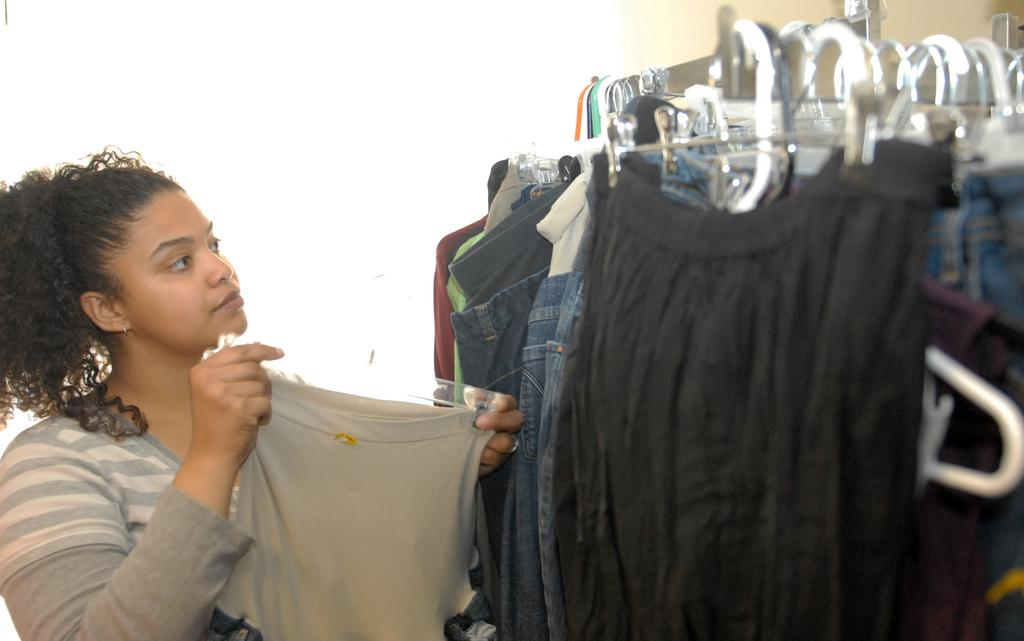What is the main subject of the image? There is a woman standing in the center of the image. What is the woman holding in the image? The woman is holding a cloth. What can be seen on the right side of the image? There are hangers and clothes on the right side of the image. What is visible in the background of the image? There is a wall in the background of the image. What type of shirt is hanging on the rail in the image? There is no rail or shirt present in the image. 